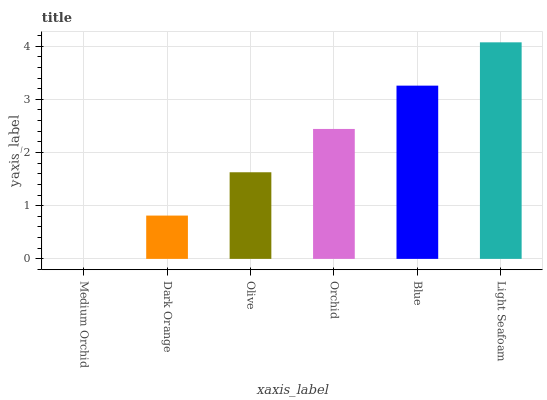Is Medium Orchid the minimum?
Answer yes or no. Yes. Is Light Seafoam the maximum?
Answer yes or no. Yes. Is Dark Orange the minimum?
Answer yes or no. No. Is Dark Orange the maximum?
Answer yes or no. No. Is Dark Orange greater than Medium Orchid?
Answer yes or no. Yes. Is Medium Orchid less than Dark Orange?
Answer yes or no. Yes. Is Medium Orchid greater than Dark Orange?
Answer yes or no. No. Is Dark Orange less than Medium Orchid?
Answer yes or no. No. Is Orchid the high median?
Answer yes or no. Yes. Is Olive the low median?
Answer yes or no. Yes. Is Medium Orchid the high median?
Answer yes or no. No. Is Light Seafoam the low median?
Answer yes or no. No. 